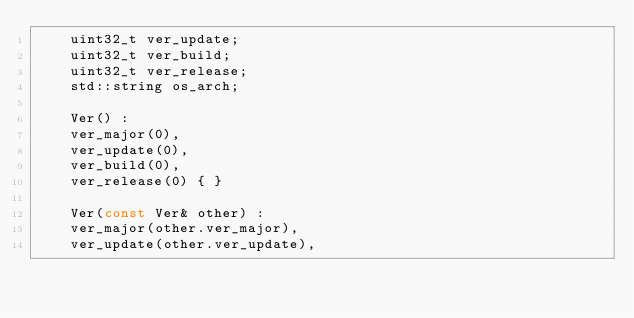Convert code to text. <code><loc_0><loc_0><loc_500><loc_500><_C++_>    uint32_t ver_update;
    uint32_t ver_build;
    uint32_t ver_release;
    std::string os_arch;
    
    Ver() :
    ver_major(0),
    ver_update(0),
    ver_build(0),
    ver_release(0) { }
    
    Ver(const Ver& other) :
    ver_major(other.ver_major),
    ver_update(other.ver_update),</code> 